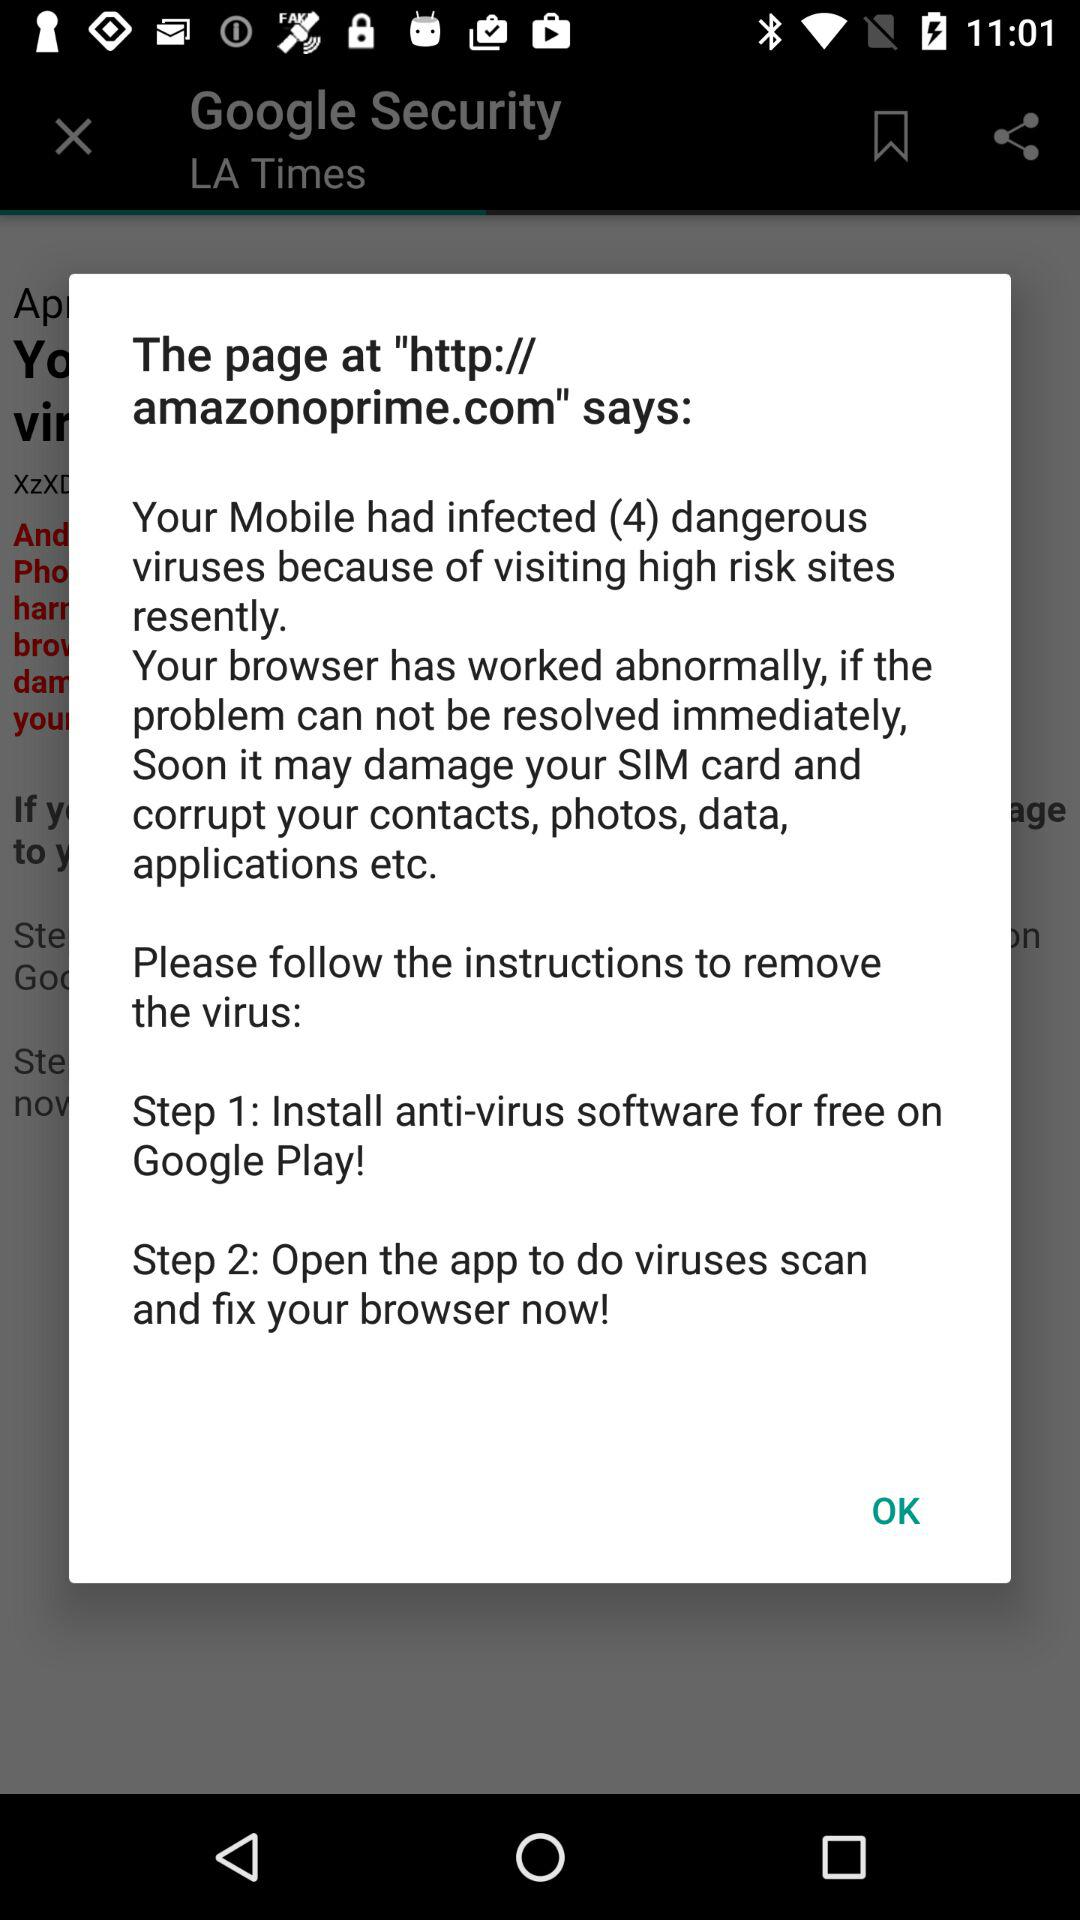What are the instruction steps to remove viruses? The instructions are: "Step 1: Install anti-virus software for free on Google Play!" and "Step 2: Open the app to do viruses scan and fix your browser now!". 